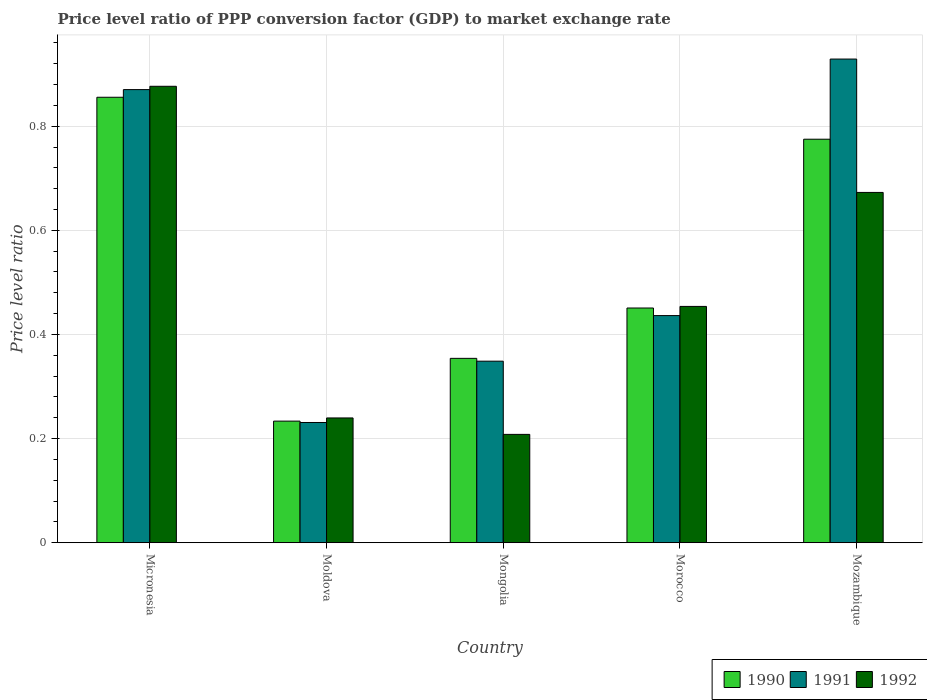How many groups of bars are there?
Make the answer very short. 5. Are the number of bars on each tick of the X-axis equal?
Keep it short and to the point. Yes. How many bars are there on the 4th tick from the left?
Your answer should be compact. 3. How many bars are there on the 2nd tick from the right?
Your response must be concise. 3. What is the label of the 3rd group of bars from the left?
Ensure brevity in your answer.  Mongolia. What is the price level ratio in 1991 in Moldova?
Give a very brief answer. 0.23. Across all countries, what is the maximum price level ratio in 1991?
Your answer should be compact. 0.93. Across all countries, what is the minimum price level ratio in 1992?
Your answer should be very brief. 0.21. In which country was the price level ratio in 1991 maximum?
Provide a short and direct response. Mozambique. In which country was the price level ratio in 1992 minimum?
Give a very brief answer. Mongolia. What is the total price level ratio in 1990 in the graph?
Your response must be concise. 2.67. What is the difference between the price level ratio in 1991 in Mongolia and that in Morocco?
Your response must be concise. -0.09. What is the difference between the price level ratio in 1992 in Micronesia and the price level ratio in 1991 in Mozambique?
Your answer should be compact. -0.05. What is the average price level ratio in 1992 per country?
Your answer should be very brief. 0.49. What is the difference between the price level ratio of/in 1991 and price level ratio of/in 1992 in Morocco?
Offer a terse response. -0.02. What is the ratio of the price level ratio in 1991 in Moldova to that in Morocco?
Keep it short and to the point. 0.53. Is the price level ratio in 1992 in Micronesia less than that in Morocco?
Your answer should be very brief. No. What is the difference between the highest and the second highest price level ratio in 1992?
Your answer should be very brief. 0.2. What is the difference between the highest and the lowest price level ratio in 1991?
Keep it short and to the point. 0.7. In how many countries, is the price level ratio in 1991 greater than the average price level ratio in 1991 taken over all countries?
Your answer should be compact. 2. What is the difference between two consecutive major ticks on the Y-axis?
Your response must be concise. 0.2. Are the values on the major ticks of Y-axis written in scientific E-notation?
Offer a terse response. No. How many legend labels are there?
Your answer should be compact. 3. What is the title of the graph?
Provide a succinct answer. Price level ratio of PPP conversion factor (GDP) to market exchange rate. Does "1970" appear as one of the legend labels in the graph?
Provide a short and direct response. No. What is the label or title of the Y-axis?
Provide a short and direct response. Price level ratio. What is the Price level ratio of 1990 in Micronesia?
Ensure brevity in your answer.  0.86. What is the Price level ratio in 1991 in Micronesia?
Your answer should be compact. 0.87. What is the Price level ratio of 1992 in Micronesia?
Keep it short and to the point. 0.88. What is the Price level ratio of 1990 in Moldova?
Give a very brief answer. 0.23. What is the Price level ratio in 1991 in Moldova?
Your answer should be compact. 0.23. What is the Price level ratio in 1992 in Moldova?
Keep it short and to the point. 0.24. What is the Price level ratio of 1990 in Mongolia?
Provide a short and direct response. 0.35. What is the Price level ratio of 1991 in Mongolia?
Your answer should be very brief. 0.35. What is the Price level ratio of 1992 in Mongolia?
Offer a very short reply. 0.21. What is the Price level ratio of 1990 in Morocco?
Your answer should be very brief. 0.45. What is the Price level ratio of 1991 in Morocco?
Your response must be concise. 0.44. What is the Price level ratio of 1992 in Morocco?
Your response must be concise. 0.45. What is the Price level ratio in 1990 in Mozambique?
Offer a terse response. 0.78. What is the Price level ratio in 1991 in Mozambique?
Your answer should be very brief. 0.93. What is the Price level ratio of 1992 in Mozambique?
Ensure brevity in your answer.  0.67. Across all countries, what is the maximum Price level ratio of 1990?
Ensure brevity in your answer.  0.86. Across all countries, what is the maximum Price level ratio of 1991?
Offer a very short reply. 0.93. Across all countries, what is the maximum Price level ratio in 1992?
Keep it short and to the point. 0.88. Across all countries, what is the minimum Price level ratio in 1990?
Give a very brief answer. 0.23. Across all countries, what is the minimum Price level ratio in 1991?
Ensure brevity in your answer.  0.23. Across all countries, what is the minimum Price level ratio of 1992?
Provide a succinct answer. 0.21. What is the total Price level ratio in 1990 in the graph?
Make the answer very short. 2.67. What is the total Price level ratio of 1991 in the graph?
Give a very brief answer. 2.82. What is the total Price level ratio in 1992 in the graph?
Offer a terse response. 2.45. What is the difference between the Price level ratio of 1990 in Micronesia and that in Moldova?
Your answer should be compact. 0.62. What is the difference between the Price level ratio in 1991 in Micronesia and that in Moldova?
Your response must be concise. 0.64. What is the difference between the Price level ratio in 1992 in Micronesia and that in Moldova?
Provide a short and direct response. 0.64. What is the difference between the Price level ratio in 1990 in Micronesia and that in Mongolia?
Provide a short and direct response. 0.5. What is the difference between the Price level ratio of 1991 in Micronesia and that in Mongolia?
Make the answer very short. 0.52. What is the difference between the Price level ratio in 1992 in Micronesia and that in Mongolia?
Offer a very short reply. 0.67. What is the difference between the Price level ratio of 1990 in Micronesia and that in Morocco?
Your answer should be very brief. 0.4. What is the difference between the Price level ratio in 1991 in Micronesia and that in Morocco?
Your response must be concise. 0.43. What is the difference between the Price level ratio in 1992 in Micronesia and that in Morocco?
Offer a terse response. 0.42. What is the difference between the Price level ratio of 1990 in Micronesia and that in Mozambique?
Make the answer very short. 0.08. What is the difference between the Price level ratio of 1991 in Micronesia and that in Mozambique?
Make the answer very short. -0.06. What is the difference between the Price level ratio in 1992 in Micronesia and that in Mozambique?
Provide a short and direct response. 0.2. What is the difference between the Price level ratio of 1990 in Moldova and that in Mongolia?
Provide a succinct answer. -0.12. What is the difference between the Price level ratio in 1991 in Moldova and that in Mongolia?
Provide a short and direct response. -0.12. What is the difference between the Price level ratio in 1992 in Moldova and that in Mongolia?
Provide a succinct answer. 0.03. What is the difference between the Price level ratio of 1990 in Moldova and that in Morocco?
Provide a short and direct response. -0.22. What is the difference between the Price level ratio of 1991 in Moldova and that in Morocco?
Make the answer very short. -0.21. What is the difference between the Price level ratio in 1992 in Moldova and that in Morocco?
Ensure brevity in your answer.  -0.21. What is the difference between the Price level ratio in 1990 in Moldova and that in Mozambique?
Offer a terse response. -0.54. What is the difference between the Price level ratio of 1991 in Moldova and that in Mozambique?
Offer a terse response. -0.7. What is the difference between the Price level ratio in 1992 in Moldova and that in Mozambique?
Keep it short and to the point. -0.43. What is the difference between the Price level ratio of 1990 in Mongolia and that in Morocco?
Make the answer very short. -0.1. What is the difference between the Price level ratio of 1991 in Mongolia and that in Morocco?
Your response must be concise. -0.09. What is the difference between the Price level ratio in 1992 in Mongolia and that in Morocco?
Provide a succinct answer. -0.25. What is the difference between the Price level ratio of 1990 in Mongolia and that in Mozambique?
Your answer should be very brief. -0.42. What is the difference between the Price level ratio of 1991 in Mongolia and that in Mozambique?
Offer a very short reply. -0.58. What is the difference between the Price level ratio in 1992 in Mongolia and that in Mozambique?
Ensure brevity in your answer.  -0.46. What is the difference between the Price level ratio in 1990 in Morocco and that in Mozambique?
Ensure brevity in your answer.  -0.32. What is the difference between the Price level ratio of 1991 in Morocco and that in Mozambique?
Keep it short and to the point. -0.49. What is the difference between the Price level ratio in 1992 in Morocco and that in Mozambique?
Offer a very short reply. -0.22. What is the difference between the Price level ratio of 1990 in Micronesia and the Price level ratio of 1991 in Moldova?
Offer a very short reply. 0.62. What is the difference between the Price level ratio of 1990 in Micronesia and the Price level ratio of 1992 in Moldova?
Ensure brevity in your answer.  0.62. What is the difference between the Price level ratio of 1991 in Micronesia and the Price level ratio of 1992 in Moldova?
Your response must be concise. 0.63. What is the difference between the Price level ratio of 1990 in Micronesia and the Price level ratio of 1991 in Mongolia?
Make the answer very short. 0.51. What is the difference between the Price level ratio of 1990 in Micronesia and the Price level ratio of 1992 in Mongolia?
Your answer should be compact. 0.65. What is the difference between the Price level ratio in 1991 in Micronesia and the Price level ratio in 1992 in Mongolia?
Your answer should be very brief. 0.66. What is the difference between the Price level ratio of 1990 in Micronesia and the Price level ratio of 1991 in Morocco?
Offer a terse response. 0.42. What is the difference between the Price level ratio of 1990 in Micronesia and the Price level ratio of 1992 in Morocco?
Provide a short and direct response. 0.4. What is the difference between the Price level ratio in 1991 in Micronesia and the Price level ratio in 1992 in Morocco?
Offer a terse response. 0.42. What is the difference between the Price level ratio in 1990 in Micronesia and the Price level ratio in 1991 in Mozambique?
Offer a very short reply. -0.07. What is the difference between the Price level ratio of 1990 in Micronesia and the Price level ratio of 1992 in Mozambique?
Give a very brief answer. 0.18. What is the difference between the Price level ratio in 1991 in Micronesia and the Price level ratio in 1992 in Mozambique?
Your answer should be compact. 0.2. What is the difference between the Price level ratio of 1990 in Moldova and the Price level ratio of 1991 in Mongolia?
Your answer should be very brief. -0.12. What is the difference between the Price level ratio in 1990 in Moldova and the Price level ratio in 1992 in Mongolia?
Give a very brief answer. 0.03. What is the difference between the Price level ratio in 1991 in Moldova and the Price level ratio in 1992 in Mongolia?
Provide a short and direct response. 0.02. What is the difference between the Price level ratio in 1990 in Moldova and the Price level ratio in 1991 in Morocco?
Your answer should be very brief. -0.2. What is the difference between the Price level ratio of 1990 in Moldova and the Price level ratio of 1992 in Morocco?
Your response must be concise. -0.22. What is the difference between the Price level ratio in 1991 in Moldova and the Price level ratio in 1992 in Morocco?
Offer a very short reply. -0.22. What is the difference between the Price level ratio in 1990 in Moldova and the Price level ratio in 1991 in Mozambique?
Offer a terse response. -0.7. What is the difference between the Price level ratio of 1990 in Moldova and the Price level ratio of 1992 in Mozambique?
Ensure brevity in your answer.  -0.44. What is the difference between the Price level ratio of 1991 in Moldova and the Price level ratio of 1992 in Mozambique?
Offer a terse response. -0.44. What is the difference between the Price level ratio in 1990 in Mongolia and the Price level ratio in 1991 in Morocco?
Offer a very short reply. -0.08. What is the difference between the Price level ratio of 1990 in Mongolia and the Price level ratio of 1992 in Morocco?
Offer a terse response. -0.1. What is the difference between the Price level ratio of 1991 in Mongolia and the Price level ratio of 1992 in Morocco?
Make the answer very short. -0.11. What is the difference between the Price level ratio in 1990 in Mongolia and the Price level ratio in 1991 in Mozambique?
Provide a succinct answer. -0.57. What is the difference between the Price level ratio in 1990 in Mongolia and the Price level ratio in 1992 in Mozambique?
Give a very brief answer. -0.32. What is the difference between the Price level ratio in 1991 in Mongolia and the Price level ratio in 1992 in Mozambique?
Provide a short and direct response. -0.32. What is the difference between the Price level ratio of 1990 in Morocco and the Price level ratio of 1991 in Mozambique?
Your answer should be very brief. -0.48. What is the difference between the Price level ratio of 1990 in Morocco and the Price level ratio of 1992 in Mozambique?
Ensure brevity in your answer.  -0.22. What is the difference between the Price level ratio in 1991 in Morocco and the Price level ratio in 1992 in Mozambique?
Offer a very short reply. -0.24. What is the average Price level ratio in 1990 per country?
Keep it short and to the point. 0.53. What is the average Price level ratio of 1991 per country?
Your response must be concise. 0.56. What is the average Price level ratio in 1992 per country?
Give a very brief answer. 0.49. What is the difference between the Price level ratio in 1990 and Price level ratio in 1991 in Micronesia?
Keep it short and to the point. -0.01. What is the difference between the Price level ratio of 1990 and Price level ratio of 1992 in Micronesia?
Provide a short and direct response. -0.02. What is the difference between the Price level ratio in 1991 and Price level ratio in 1992 in Micronesia?
Your answer should be very brief. -0.01. What is the difference between the Price level ratio of 1990 and Price level ratio of 1991 in Moldova?
Your answer should be very brief. 0. What is the difference between the Price level ratio of 1990 and Price level ratio of 1992 in Moldova?
Your response must be concise. -0.01. What is the difference between the Price level ratio of 1991 and Price level ratio of 1992 in Moldova?
Offer a terse response. -0.01. What is the difference between the Price level ratio of 1990 and Price level ratio of 1991 in Mongolia?
Provide a succinct answer. 0.01. What is the difference between the Price level ratio in 1990 and Price level ratio in 1992 in Mongolia?
Make the answer very short. 0.15. What is the difference between the Price level ratio of 1991 and Price level ratio of 1992 in Mongolia?
Keep it short and to the point. 0.14. What is the difference between the Price level ratio in 1990 and Price level ratio in 1991 in Morocco?
Provide a short and direct response. 0.01. What is the difference between the Price level ratio of 1990 and Price level ratio of 1992 in Morocco?
Your answer should be compact. -0. What is the difference between the Price level ratio of 1991 and Price level ratio of 1992 in Morocco?
Your response must be concise. -0.02. What is the difference between the Price level ratio of 1990 and Price level ratio of 1991 in Mozambique?
Your answer should be compact. -0.15. What is the difference between the Price level ratio in 1990 and Price level ratio in 1992 in Mozambique?
Provide a succinct answer. 0.1. What is the difference between the Price level ratio of 1991 and Price level ratio of 1992 in Mozambique?
Your response must be concise. 0.26. What is the ratio of the Price level ratio in 1990 in Micronesia to that in Moldova?
Provide a succinct answer. 3.66. What is the ratio of the Price level ratio of 1991 in Micronesia to that in Moldova?
Provide a succinct answer. 3.77. What is the ratio of the Price level ratio of 1992 in Micronesia to that in Moldova?
Ensure brevity in your answer.  3.66. What is the ratio of the Price level ratio in 1990 in Micronesia to that in Mongolia?
Your response must be concise. 2.42. What is the ratio of the Price level ratio of 1991 in Micronesia to that in Mongolia?
Make the answer very short. 2.5. What is the ratio of the Price level ratio of 1992 in Micronesia to that in Mongolia?
Offer a very short reply. 4.21. What is the ratio of the Price level ratio of 1990 in Micronesia to that in Morocco?
Offer a terse response. 1.9. What is the ratio of the Price level ratio of 1991 in Micronesia to that in Morocco?
Provide a short and direct response. 1.99. What is the ratio of the Price level ratio in 1992 in Micronesia to that in Morocco?
Your response must be concise. 1.93. What is the ratio of the Price level ratio in 1990 in Micronesia to that in Mozambique?
Provide a succinct answer. 1.1. What is the ratio of the Price level ratio of 1991 in Micronesia to that in Mozambique?
Make the answer very short. 0.94. What is the ratio of the Price level ratio of 1992 in Micronesia to that in Mozambique?
Offer a terse response. 1.3. What is the ratio of the Price level ratio of 1990 in Moldova to that in Mongolia?
Provide a succinct answer. 0.66. What is the ratio of the Price level ratio in 1991 in Moldova to that in Mongolia?
Provide a succinct answer. 0.66. What is the ratio of the Price level ratio of 1992 in Moldova to that in Mongolia?
Your answer should be compact. 1.15. What is the ratio of the Price level ratio of 1990 in Moldova to that in Morocco?
Offer a terse response. 0.52. What is the ratio of the Price level ratio of 1991 in Moldova to that in Morocco?
Your answer should be compact. 0.53. What is the ratio of the Price level ratio in 1992 in Moldova to that in Morocco?
Your answer should be compact. 0.53. What is the ratio of the Price level ratio in 1990 in Moldova to that in Mozambique?
Keep it short and to the point. 0.3. What is the ratio of the Price level ratio of 1991 in Moldova to that in Mozambique?
Offer a very short reply. 0.25. What is the ratio of the Price level ratio in 1992 in Moldova to that in Mozambique?
Give a very brief answer. 0.36. What is the ratio of the Price level ratio of 1990 in Mongolia to that in Morocco?
Your response must be concise. 0.79. What is the ratio of the Price level ratio of 1991 in Mongolia to that in Morocco?
Your response must be concise. 0.8. What is the ratio of the Price level ratio in 1992 in Mongolia to that in Morocco?
Offer a very short reply. 0.46. What is the ratio of the Price level ratio in 1990 in Mongolia to that in Mozambique?
Make the answer very short. 0.46. What is the ratio of the Price level ratio of 1991 in Mongolia to that in Mozambique?
Give a very brief answer. 0.38. What is the ratio of the Price level ratio of 1992 in Mongolia to that in Mozambique?
Provide a succinct answer. 0.31. What is the ratio of the Price level ratio in 1990 in Morocco to that in Mozambique?
Provide a short and direct response. 0.58. What is the ratio of the Price level ratio of 1991 in Morocco to that in Mozambique?
Offer a terse response. 0.47. What is the ratio of the Price level ratio of 1992 in Morocco to that in Mozambique?
Keep it short and to the point. 0.67. What is the difference between the highest and the second highest Price level ratio of 1990?
Keep it short and to the point. 0.08. What is the difference between the highest and the second highest Price level ratio of 1991?
Your response must be concise. 0.06. What is the difference between the highest and the second highest Price level ratio in 1992?
Make the answer very short. 0.2. What is the difference between the highest and the lowest Price level ratio of 1990?
Give a very brief answer. 0.62. What is the difference between the highest and the lowest Price level ratio of 1991?
Your response must be concise. 0.7. What is the difference between the highest and the lowest Price level ratio in 1992?
Ensure brevity in your answer.  0.67. 